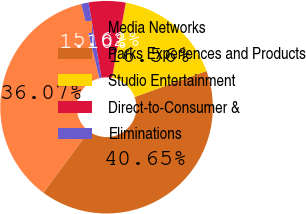<chart> <loc_0><loc_0><loc_500><loc_500><pie_chart><fcel>Media Networks<fcel>Parks Experiences and Products<fcel>Studio Entertainment<fcel>Direct-to-Consumer &<fcel>Eliminations<nl><fcel>36.07%<fcel>40.65%<fcel>16.56%<fcel>5.62%<fcel>1.1%<nl></chart> 